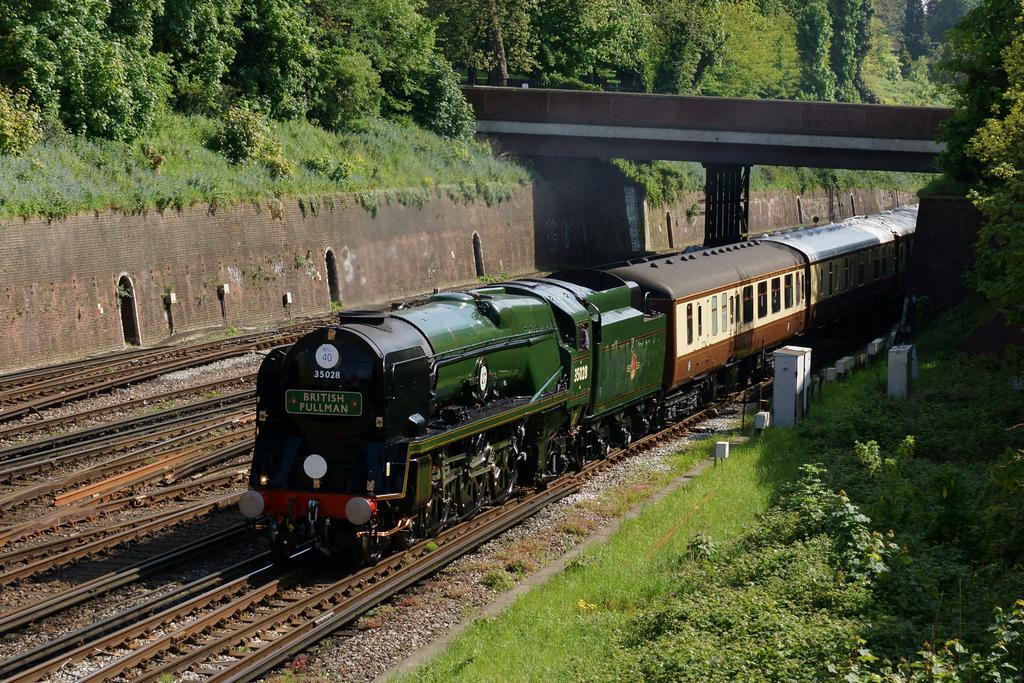Describe this image in one or two sentences. In this image I can see the train on the track. The train is colorful and I can see something is written on the train. To the side of the train there are many trees. I can also see the bridge to the top of the train. 